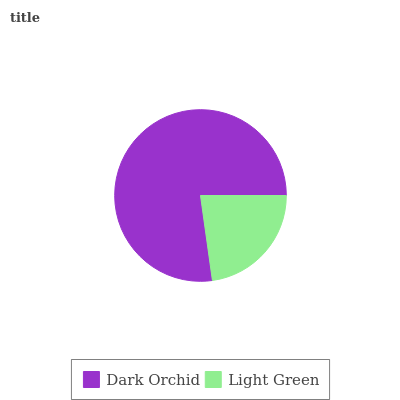Is Light Green the minimum?
Answer yes or no. Yes. Is Dark Orchid the maximum?
Answer yes or no. Yes. Is Light Green the maximum?
Answer yes or no. No. Is Dark Orchid greater than Light Green?
Answer yes or no. Yes. Is Light Green less than Dark Orchid?
Answer yes or no. Yes. Is Light Green greater than Dark Orchid?
Answer yes or no. No. Is Dark Orchid less than Light Green?
Answer yes or no. No. Is Dark Orchid the high median?
Answer yes or no. Yes. Is Light Green the low median?
Answer yes or no. Yes. Is Light Green the high median?
Answer yes or no. No. Is Dark Orchid the low median?
Answer yes or no. No. 